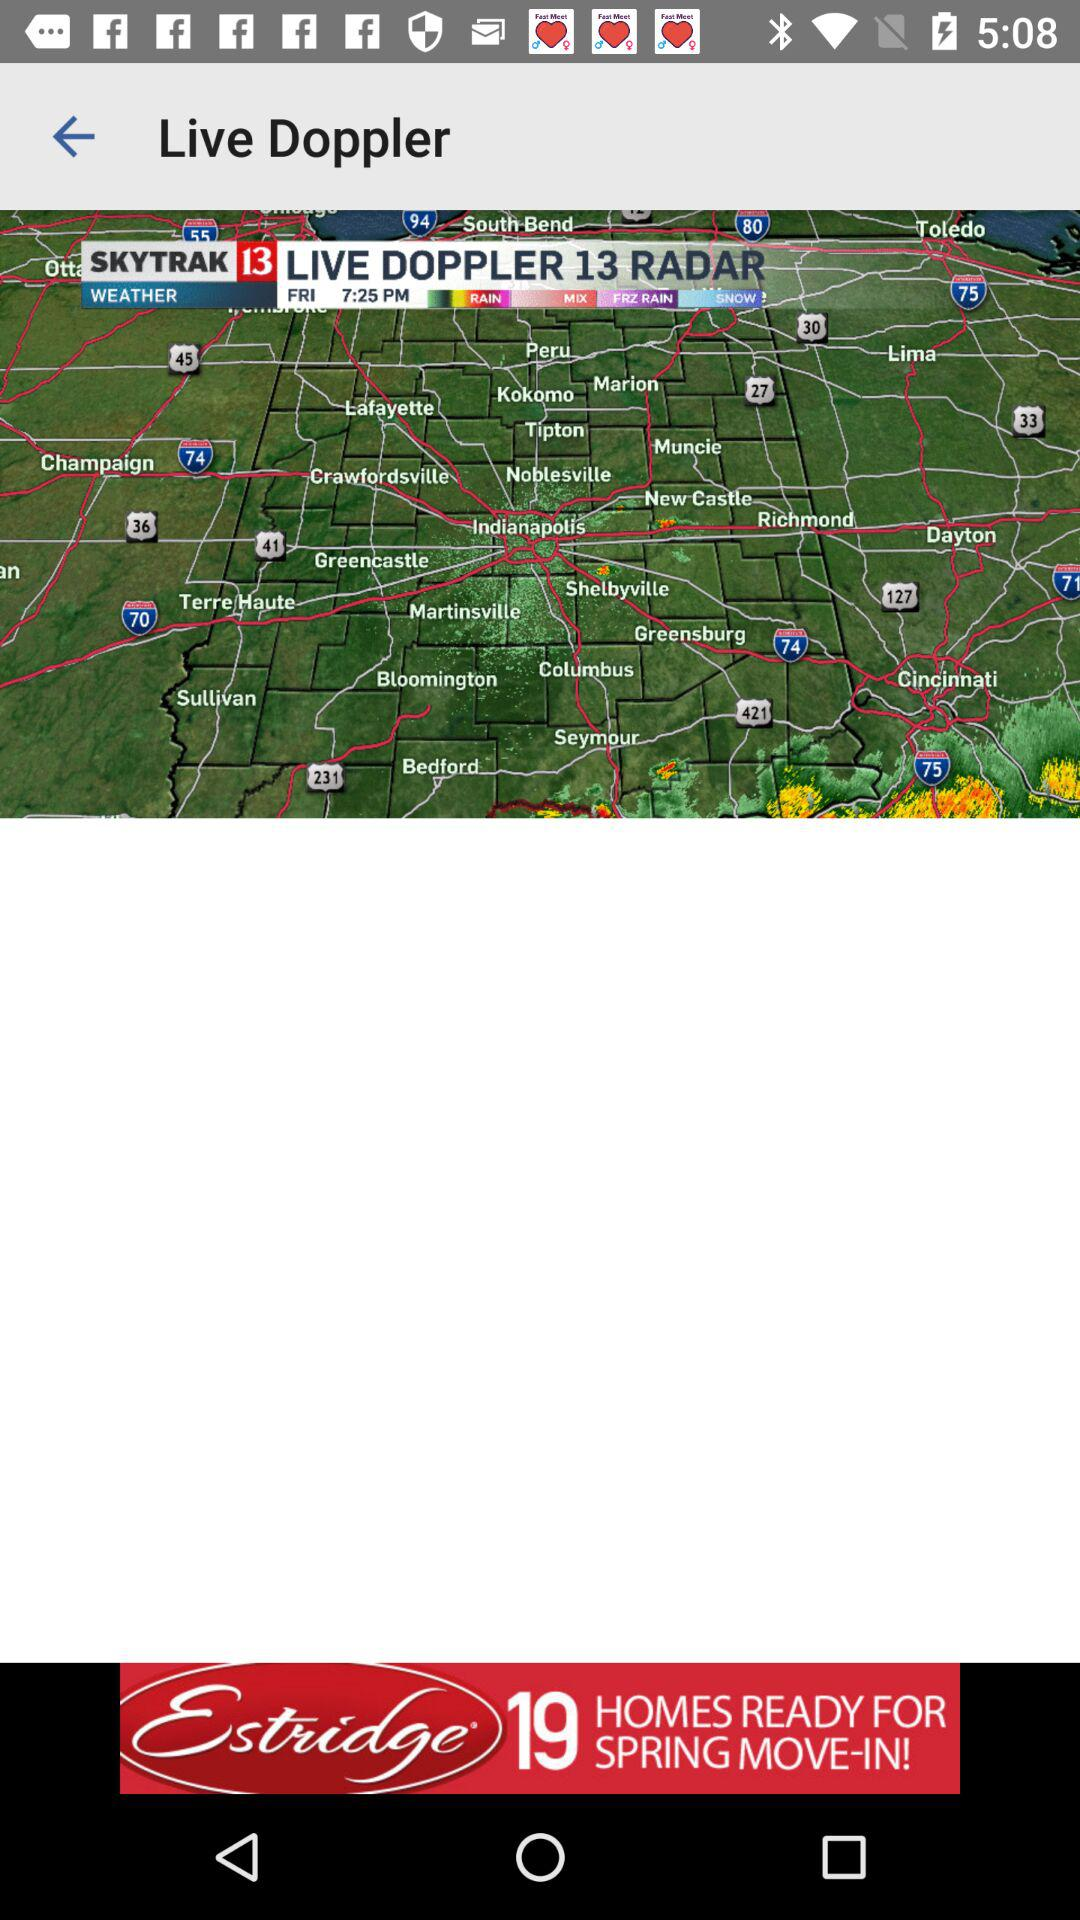What is the app name?
When the provided information is insufficient, respond with <no answer>. <no answer> 